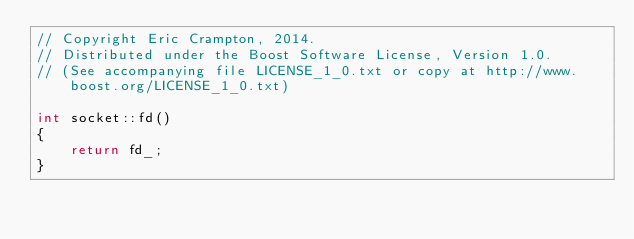<code> <loc_0><loc_0><loc_500><loc_500><_C++_>// Copyright Eric Crampton, 2014.
// Distributed under the Boost Software License, Version 1.0.
// (See accompanying file LICENSE_1_0.txt or copy at http://www.boost.org/LICENSE_1_0.txt)

int socket::fd()
{
    return fd_;
}
</code> 